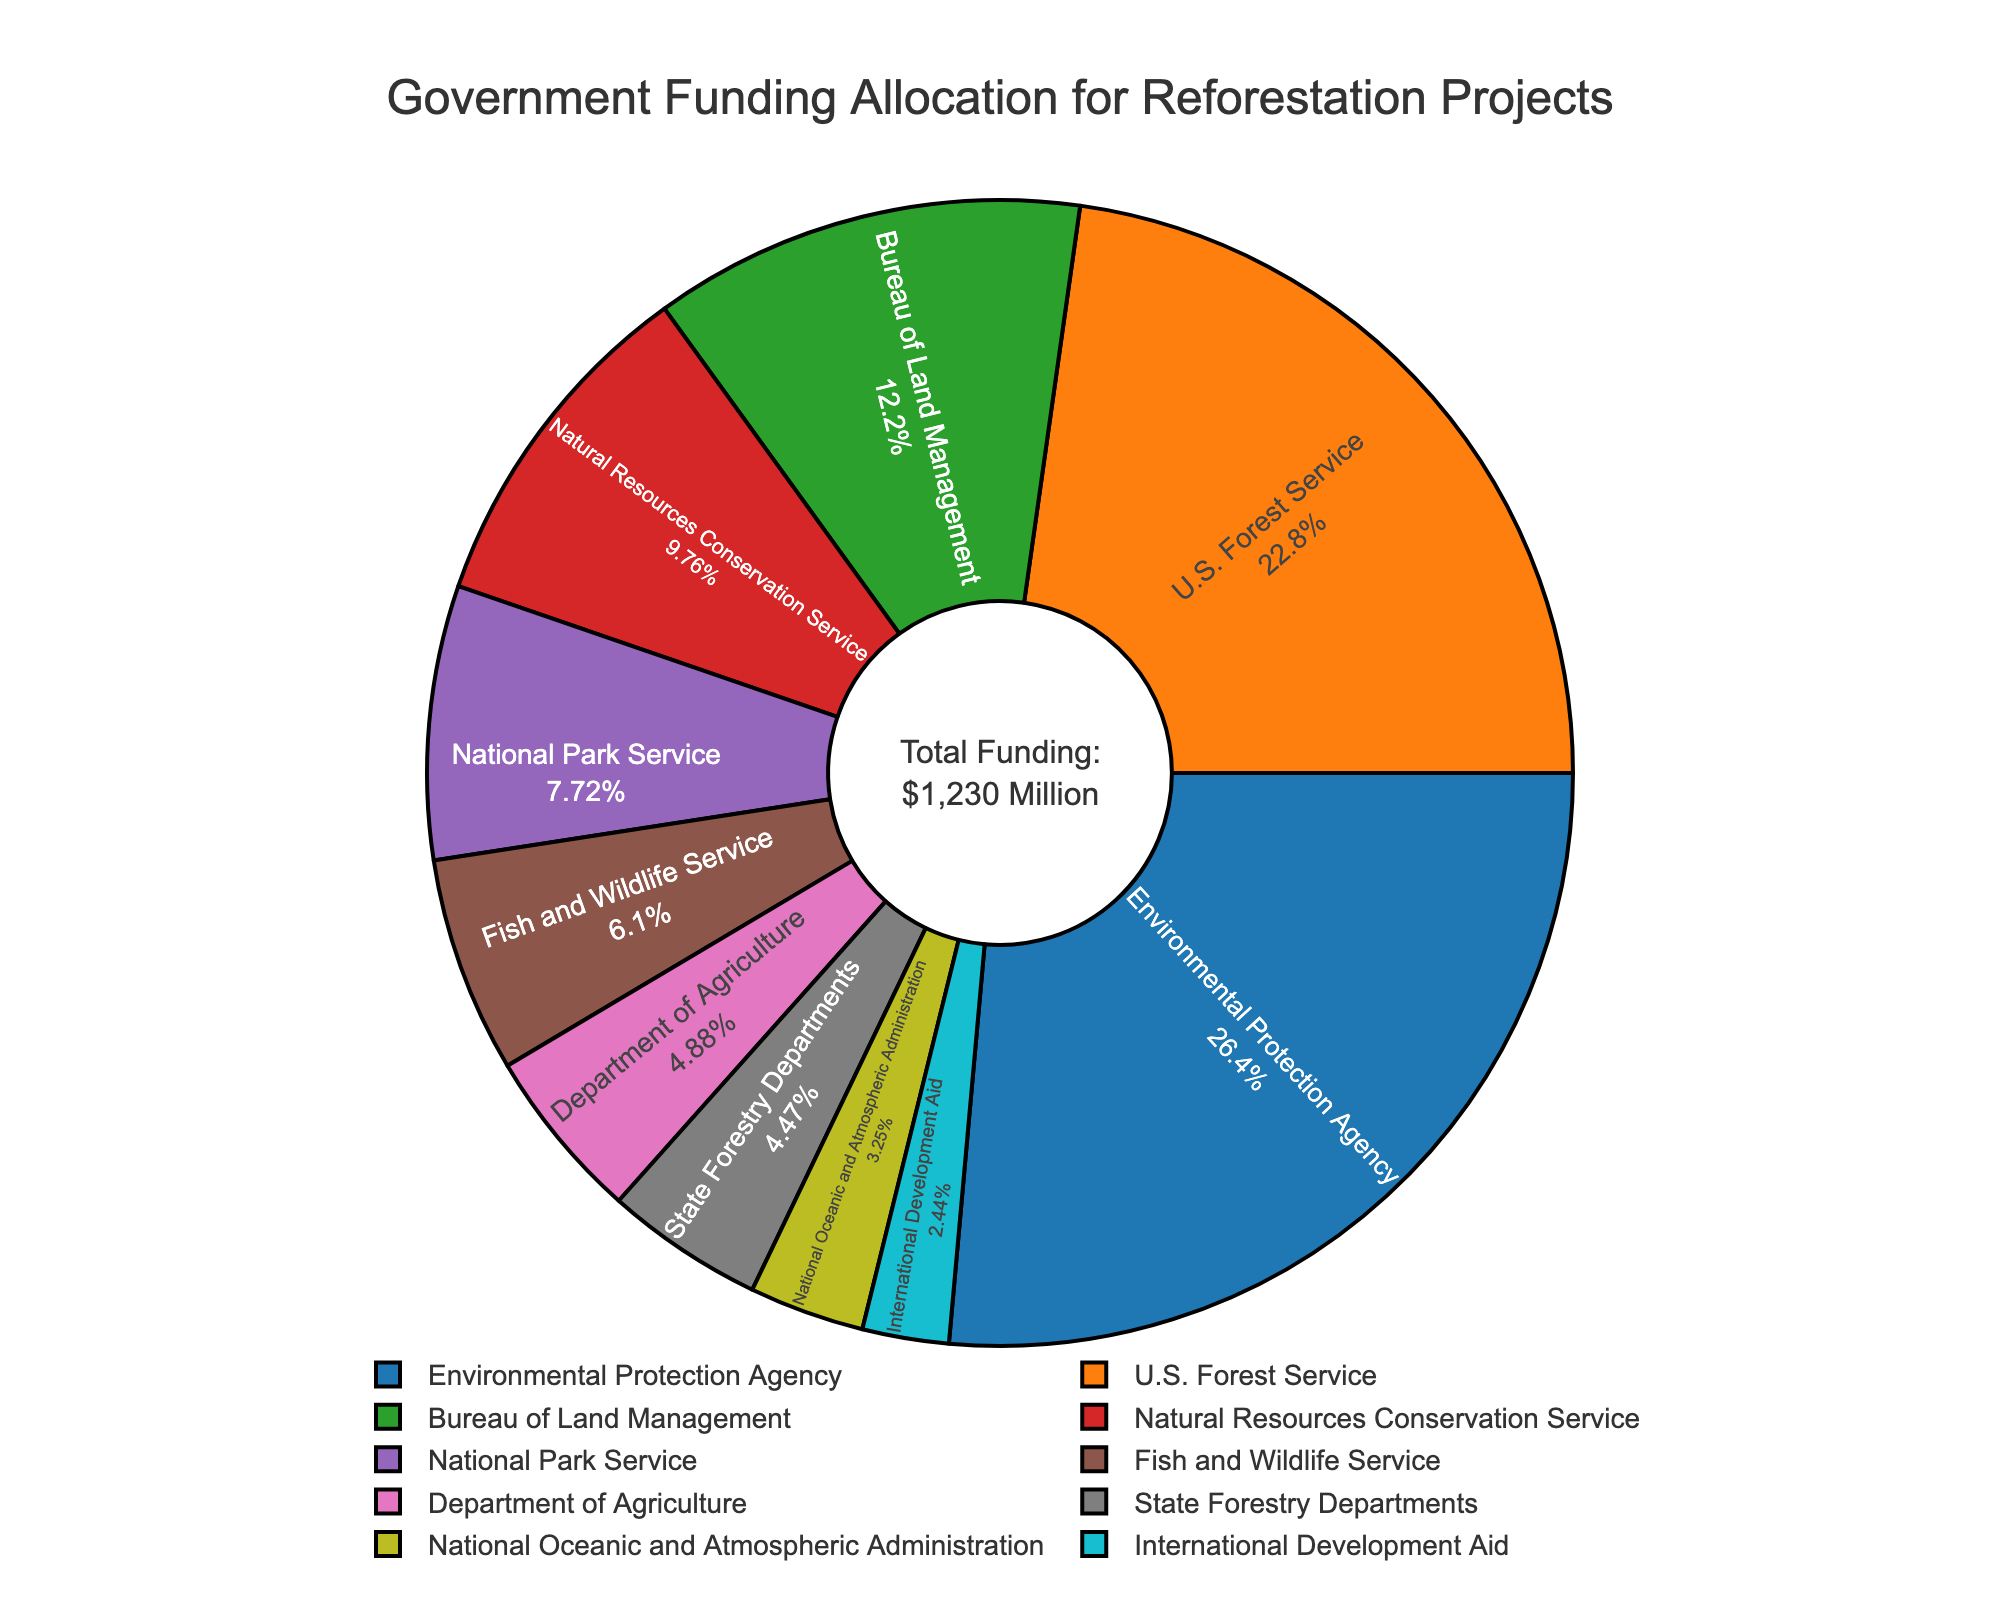What percentage of the total funding is allocated to the Environmental Protection Agency? The pie chart provides the funding shares in percent for each government agency, and according to the labels, the Environmental Protection Agency (EPA) holds the largest space in the pie chart with 29.09%.
Answer: 29.09% Which agency receives more funding: the Bureau of Land Management or the Natural Resources Conservation Service? By comparing the segments in the pie chart, the Bureau of Land Management has a larger segment than the Natural Resources Conservation Service. The Bureau of Land Management receives 150 million USD whereas the Natural Resources Conservation Service gets 120 million USD.
Answer: Bureau of Land Management What's the difference in funding allocation between the U.S. Forest Service and Fish and Wildlife Service? We need to find the values for both agencies and subtract them. The U.S. Forest Service receives 280 million USD and the Fish and Wildlife Service receives 75 million USD. Therefore, the difference in funding is 280 - 75 = 205 million USD.
Answer: 205 million USD Which agency holds the smallest funding allocation in the pie chart? By looking at the smallest segment of the pie chart, we observe that the International Development Aid has the smallest funding allocation with 30 million USD.
Answer: International Development Aid If the funding for the U.S. Forest Service and the National Park Service is combined, what is the total funding allocation? Sum the funding allocations of the U.S. Forest Service (280 million USD) and the National Park Service (95 million USD): 280 + 95 = 375 million USD.
Answer: 375 million USD What is the total funding allocation for all the agencies combined? The pie chart has an annotation showing the total funding which is labeled as "Total Funding:$1,230 Million."
Answer: 1230 million USD What is the combined percentage share of the National Oceanic and Atmospheric Administration and International Development Aid in the total funding? Sum the individual percentages of National Oceanic and Atmospheric Administration (3.25%) and International Development Aid (2.44%) from the pie chart: 3.25% + 2.44% = 5.69%.
Answer: 5.69% Is the funding for Environmental Protection Agency greater than the combined funding for State Forestry Departments and National Oceanic and Atmospheric Administration? The funding for the Environmental Protection Agency is 325 million USD. Adding the allocations for State Forestry Departments (55 million USD) and National Oceanic and Atmospheric Administration (40 million USD) gives 55 + 40 = 95 million USD, which is less than 325 million USD.
Answer: Yes What is the average funding allocation per agency? Divide the total funding amount (1230 million USD) by the number of agencies (10). The average funding allocation is 1230 / 10 = 123 million USD.
Answer: 123 million USD 